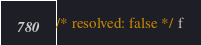Convert code to text. <code><loc_0><loc_0><loc_500><loc_500><_Scala_>/* resolved: false */ f
</code> 